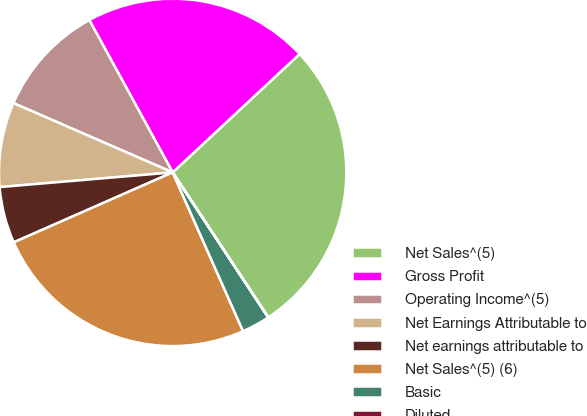<chart> <loc_0><loc_0><loc_500><loc_500><pie_chart><fcel>Net Sales^(5)<fcel>Gross Profit<fcel>Operating Income^(5)<fcel>Net Earnings Attributable to<fcel>Net earnings attributable to<fcel>Net Sales^(5) (6)<fcel>Basic<fcel>Diluted<nl><fcel>27.66%<fcel>21.02%<fcel>10.5%<fcel>7.88%<fcel>5.25%<fcel>25.04%<fcel>2.63%<fcel>0.01%<nl></chart> 